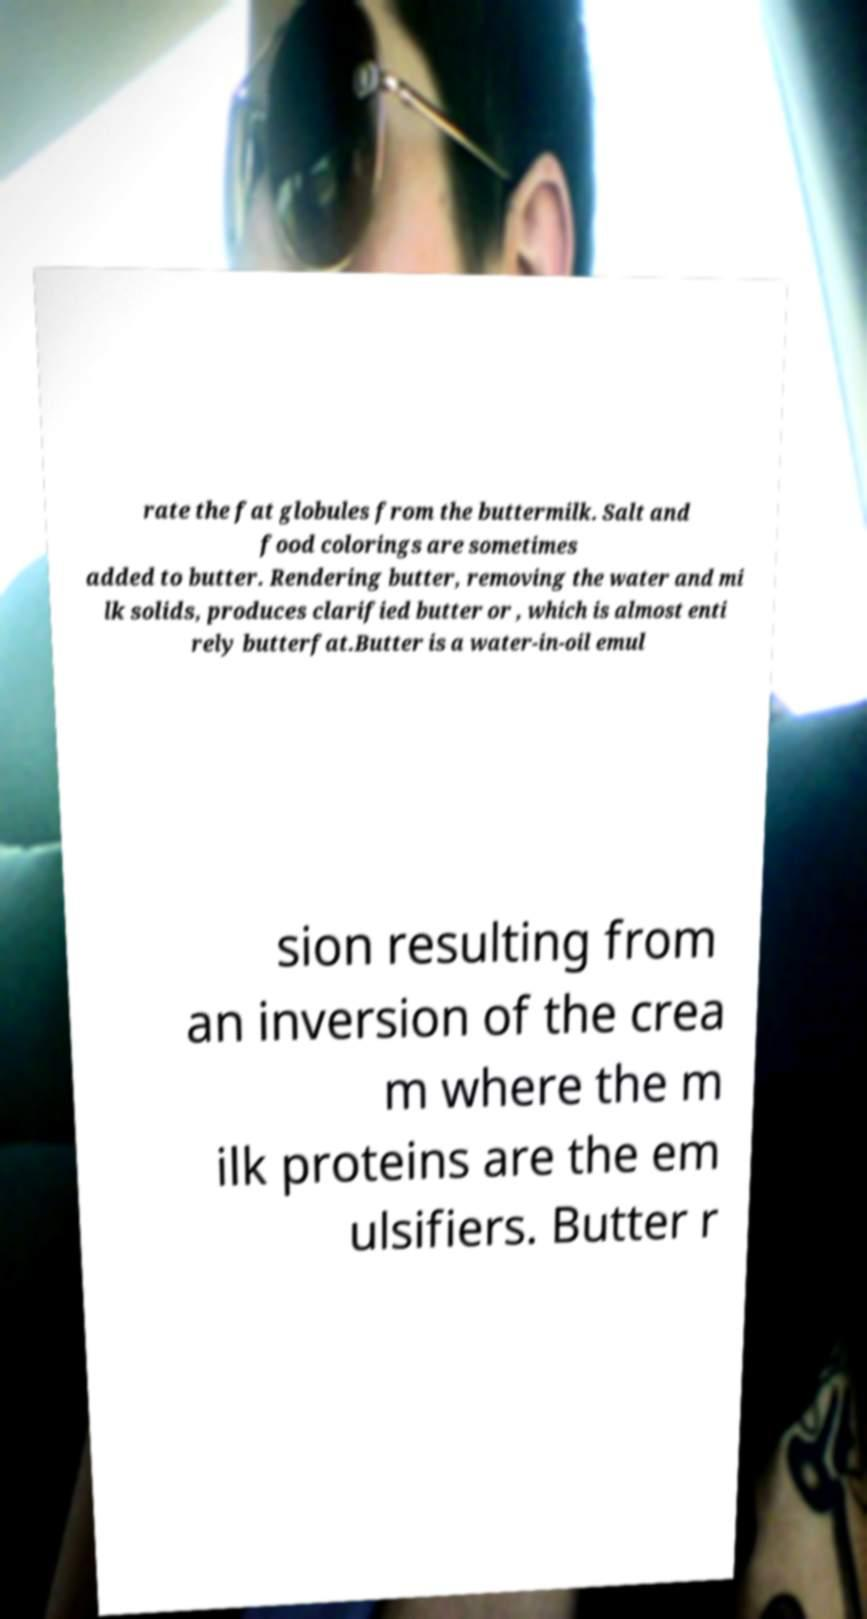Please identify and transcribe the text found in this image. rate the fat globules from the buttermilk. Salt and food colorings are sometimes added to butter. Rendering butter, removing the water and mi lk solids, produces clarified butter or , which is almost enti rely butterfat.Butter is a water-in-oil emul sion resulting from an inversion of the crea m where the m ilk proteins are the em ulsifiers. Butter r 